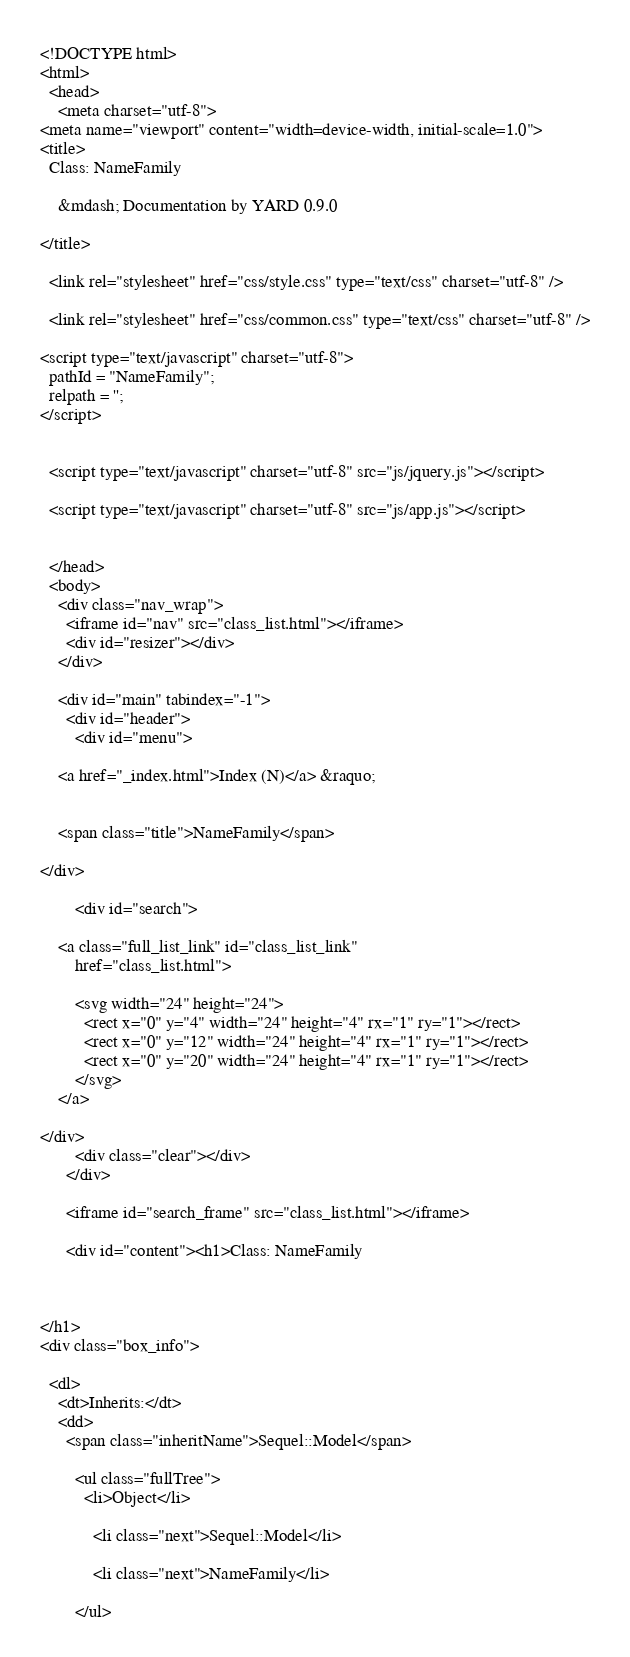Convert code to text. <code><loc_0><loc_0><loc_500><loc_500><_HTML_><!DOCTYPE html>
<html>
  <head>
    <meta charset="utf-8">
<meta name="viewport" content="width=device-width, initial-scale=1.0">
<title>
  Class: NameFamily
  
    &mdash; Documentation by YARD 0.9.0
  
</title>

  <link rel="stylesheet" href="css/style.css" type="text/css" charset="utf-8" />

  <link rel="stylesheet" href="css/common.css" type="text/css" charset="utf-8" />

<script type="text/javascript" charset="utf-8">
  pathId = "NameFamily";
  relpath = '';
</script>


  <script type="text/javascript" charset="utf-8" src="js/jquery.js"></script>

  <script type="text/javascript" charset="utf-8" src="js/app.js"></script>


  </head>
  <body>
    <div class="nav_wrap">
      <iframe id="nav" src="class_list.html"></iframe>
      <div id="resizer"></div>
    </div>

    <div id="main" tabindex="-1">
      <div id="header">
        <div id="menu">
  
    <a href="_index.html">Index (N)</a> &raquo;
    
    
    <span class="title">NameFamily</span>
  
</div>

        <div id="search">
  
    <a class="full_list_link" id="class_list_link"
        href="class_list.html">

        <svg width="24" height="24">
          <rect x="0" y="4" width="24" height="4" rx="1" ry="1"></rect>
          <rect x="0" y="12" width="24" height="4" rx="1" ry="1"></rect>
          <rect x="0" y="20" width="24" height="4" rx="1" ry="1"></rect>
        </svg>
    </a>
  
</div>
        <div class="clear"></div>
      </div>

      <iframe id="search_frame" src="class_list.html"></iframe>

      <div id="content"><h1>Class: NameFamily
  
  
  
</h1>
<div class="box_info">
  
  <dl>
    <dt>Inherits:</dt>
    <dd>
      <span class="inheritName">Sequel::Model</span>
      
        <ul class="fullTree">
          <li>Object</li>
          
            <li class="next">Sequel::Model</li>
          
            <li class="next">NameFamily</li>
          
        </ul></code> 